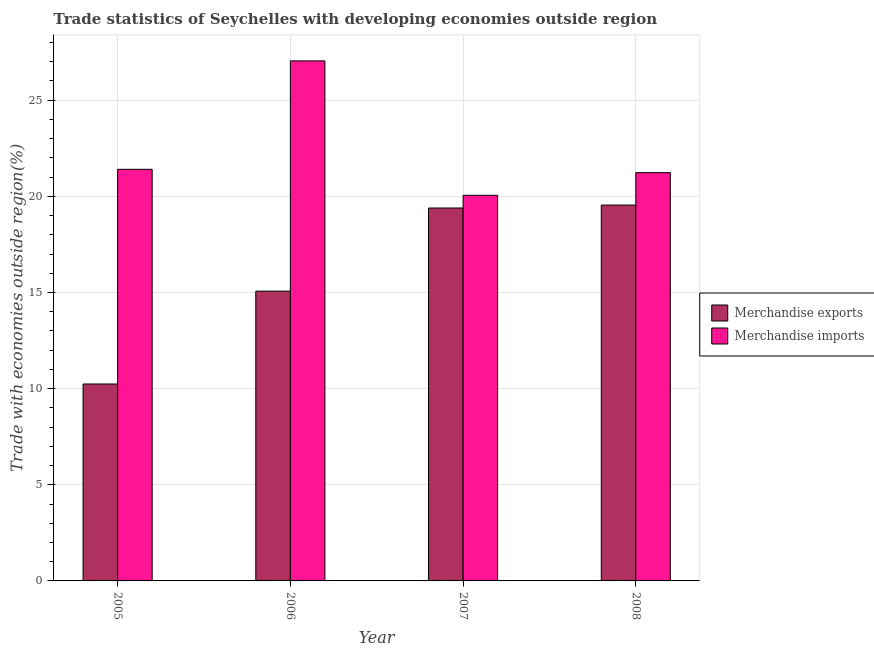How many different coloured bars are there?
Your answer should be compact. 2. Are the number of bars on each tick of the X-axis equal?
Provide a short and direct response. Yes. What is the merchandise imports in 2005?
Keep it short and to the point. 21.4. Across all years, what is the maximum merchandise imports?
Provide a succinct answer. 27.04. Across all years, what is the minimum merchandise imports?
Your answer should be compact. 20.05. In which year was the merchandise imports maximum?
Your response must be concise. 2006. In which year was the merchandise exports minimum?
Give a very brief answer. 2005. What is the total merchandise imports in the graph?
Your answer should be compact. 89.73. What is the difference between the merchandise imports in 2005 and that in 2007?
Provide a short and direct response. 1.35. What is the difference between the merchandise imports in 2005 and the merchandise exports in 2006?
Keep it short and to the point. -5.64. What is the average merchandise exports per year?
Provide a short and direct response. 16.06. In the year 2005, what is the difference between the merchandise exports and merchandise imports?
Give a very brief answer. 0. What is the ratio of the merchandise exports in 2005 to that in 2006?
Your answer should be compact. 0.68. Is the difference between the merchandise exports in 2005 and 2007 greater than the difference between the merchandise imports in 2005 and 2007?
Offer a terse response. No. What is the difference between the highest and the second highest merchandise exports?
Offer a terse response. 0.15. What is the difference between the highest and the lowest merchandise imports?
Offer a very short reply. 6.99. In how many years, is the merchandise exports greater than the average merchandise exports taken over all years?
Keep it short and to the point. 2. Is the sum of the merchandise imports in 2007 and 2008 greater than the maximum merchandise exports across all years?
Provide a succinct answer. Yes. How many bars are there?
Offer a terse response. 8. How many years are there in the graph?
Provide a succinct answer. 4. Does the graph contain any zero values?
Keep it short and to the point. No. Does the graph contain grids?
Give a very brief answer. Yes. Where does the legend appear in the graph?
Offer a terse response. Center right. How many legend labels are there?
Make the answer very short. 2. What is the title of the graph?
Offer a terse response. Trade statistics of Seychelles with developing economies outside region. What is the label or title of the Y-axis?
Your answer should be very brief. Trade with economies outside region(%). What is the Trade with economies outside region(%) of Merchandise exports in 2005?
Offer a terse response. 10.24. What is the Trade with economies outside region(%) in Merchandise imports in 2005?
Your answer should be very brief. 21.4. What is the Trade with economies outside region(%) in Merchandise exports in 2006?
Keep it short and to the point. 15.07. What is the Trade with economies outside region(%) of Merchandise imports in 2006?
Give a very brief answer. 27.04. What is the Trade with economies outside region(%) in Merchandise exports in 2007?
Offer a very short reply. 19.39. What is the Trade with economies outside region(%) in Merchandise imports in 2007?
Ensure brevity in your answer.  20.05. What is the Trade with economies outside region(%) of Merchandise exports in 2008?
Ensure brevity in your answer.  19.54. What is the Trade with economies outside region(%) of Merchandise imports in 2008?
Provide a succinct answer. 21.23. Across all years, what is the maximum Trade with economies outside region(%) of Merchandise exports?
Your response must be concise. 19.54. Across all years, what is the maximum Trade with economies outside region(%) in Merchandise imports?
Provide a succinct answer. 27.04. Across all years, what is the minimum Trade with economies outside region(%) in Merchandise exports?
Your answer should be very brief. 10.24. Across all years, what is the minimum Trade with economies outside region(%) in Merchandise imports?
Provide a succinct answer. 20.05. What is the total Trade with economies outside region(%) in Merchandise exports in the graph?
Your answer should be very brief. 64.25. What is the total Trade with economies outside region(%) in Merchandise imports in the graph?
Offer a terse response. 89.73. What is the difference between the Trade with economies outside region(%) in Merchandise exports in 2005 and that in 2006?
Make the answer very short. -4.83. What is the difference between the Trade with economies outside region(%) in Merchandise imports in 2005 and that in 2006?
Your answer should be compact. -5.64. What is the difference between the Trade with economies outside region(%) of Merchandise exports in 2005 and that in 2007?
Make the answer very short. -9.15. What is the difference between the Trade with economies outside region(%) of Merchandise imports in 2005 and that in 2007?
Keep it short and to the point. 1.35. What is the difference between the Trade with economies outside region(%) of Merchandise exports in 2005 and that in 2008?
Provide a short and direct response. -9.3. What is the difference between the Trade with economies outside region(%) in Merchandise imports in 2005 and that in 2008?
Ensure brevity in your answer.  0.17. What is the difference between the Trade with economies outside region(%) of Merchandise exports in 2006 and that in 2007?
Make the answer very short. -4.32. What is the difference between the Trade with economies outside region(%) of Merchandise imports in 2006 and that in 2007?
Your response must be concise. 6.99. What is the difference between the Trade with economies outside region(%) in Merchandise exports in 2006 and that in 2008?
Your answer should be very brief. -4.48. What is the difference between the Trade with economies outside region(%) of Merchandise imports in 2006 and that in 2008?
Your answer should be very brief. 5.81. What is the difference between the Trade with economies outside region(%) in Merchandise exports in 2007 and that in 2008?
Provide a succinct answer. -0.15. What is the difference between the Trade with economies outside region(%) in Merchandise imports in 2007 and that in 2008?
Offer a very short reply. -1.18. What is the difference between the Trade with economies outside region(%) in Merchandise exports in 2005 and the Trade with economies outside region(%) in Merchandise imports in 2006?
Keep it short and to the point. -16.8. What is the difference between the Trade with economies outside region(%) in Merchandise exports in 2005 and the Trade with economies outside region(%) in Merchandise imports in 2007?
Give a very brief answer. -9.81. What is the difference between the Trade with economies outside region(%) in Merchandise exports in 2005 and the Trade with economies outside region(%) in Merchandise imports in 2008?
Keep it short and to the point. -10.99. What is the difference between the Trade with economies outside region(%) of Merchandise exports in 2006 and the Trade with economies outside region(%) of Merchandise imports in 2007?
Keep it short and to the point. -4.98. What is the difference between the Trade with economies outside region(%) of Merchandise exports in 2006 and the Trade with economies outside region(%) of Merchandise imports in 2008?
Your response must be concise. -6.16. What is the difference between the Trade with economies outside region(%) of Merchandise exports in 2007 and the Trade with economies outside region(%) of Merchandise imports in 2008?
Keep it short and to the point. -1.84. What is the average Trade with economies outside region(%) of Merchandise exports per year?
Provide a short and direct response. 16.06. What is the average Trade with economies outside region(%) in Merchandise imports per year?
Your response must be concise. 22.43. In the year 2005, what is the difference between the Trade with economies outside region(%) in Merchandise exports and Trade with economies outside region(%) in Merchandise imports?
Ensure brevity in your answer.  -11.16. In the year 2006, what is the difference between the Trade with economies outside region(%) of Merchandise exports and Trade with economies outside region(%) of Merchandise imports?
Offer a very short reply. -11.97. In the year 2007, what is the difference between the Trade with economies outside region(%) in Merchandise exports and Trade with economies outside region(%) in Merchandise imports?
Provide a short and direct response. -0.66. In the year 2008, what is the difference between the Trade with economies outside region(%) of Merchandise exports and Trade with economies outside region(%) of Merchandise imports?
Make the answer very short. -1.69. What is the ratio of the Trade with economies outside region(%) of Merchandise exports in 2005 to that in 2006?
Your answer should be very brief. 0.68. What is the ratio of the Trade with economies outside region(%) in Merchandise imports in 2005 to that in 2006?
Your response must be concise. 0.79. What is the ratio of the Trade with economies outside region(%) of Merchandise exports in 2005 to that in 2007?
Offer a very short reply. 0.53. What is the ratio of the Trade with economies outside region(%) in Merchandise imports in 2005 to that in 2007?
Provide a short and direct response. 1.07. What is the ratio of the Trade with economies outside region(%) of Merchandise exports in 2005 to that in 2008?
Give a very brief answer. 0.52. What is the ratio of the Trade with economies outside region(%) in Merchandise imports in 2005 to that in 2008?
Offer a terse response. 1.01. What is the ratio of the Trade with economies outside region(%) in Merchandise exports in 2006 to that in 2007?
Ensure brevity in your answer.  0.78. What is the ratio of the Trade with economies outside region(%) of Merchandise imports in 2006 to that in 2007?
Provide a succinct answer. 1.35. What is the ratio of the Trade with economies outside region(%) of Merchandise exports in 2006 to that in 2008?
Ensure brevity in your answer.  0.77. What is the ratio of the Trade with economies outside region(%) of Merchandise imports in 2006 to that in 2008?
Offer a very short reply. 1.27. What is the ratio of the Trade with economies outside region(%) in Merchandise imports in 2007 to that in 2008?
Your answer should be very brief. 0.94. What is the difference between the highest and the second highest Trade with economies outside region(%) in Merchandise exports?
Ensure brevity in your answer.  0.15. What is the difference between the highest and the second highest Trade with economies outside region(%) of Merchandise imports?
Give a very brief answer. 5.64. What is the difference between the highest and the lowest Trade with economies outside region(%) of Merchandise exports?
Offer a very short reply. 9.3. What is the difference between the highest and the lowest Trade with economies outside region(%) in Merchandise imports?
Your answer should be compact. 6.99. 